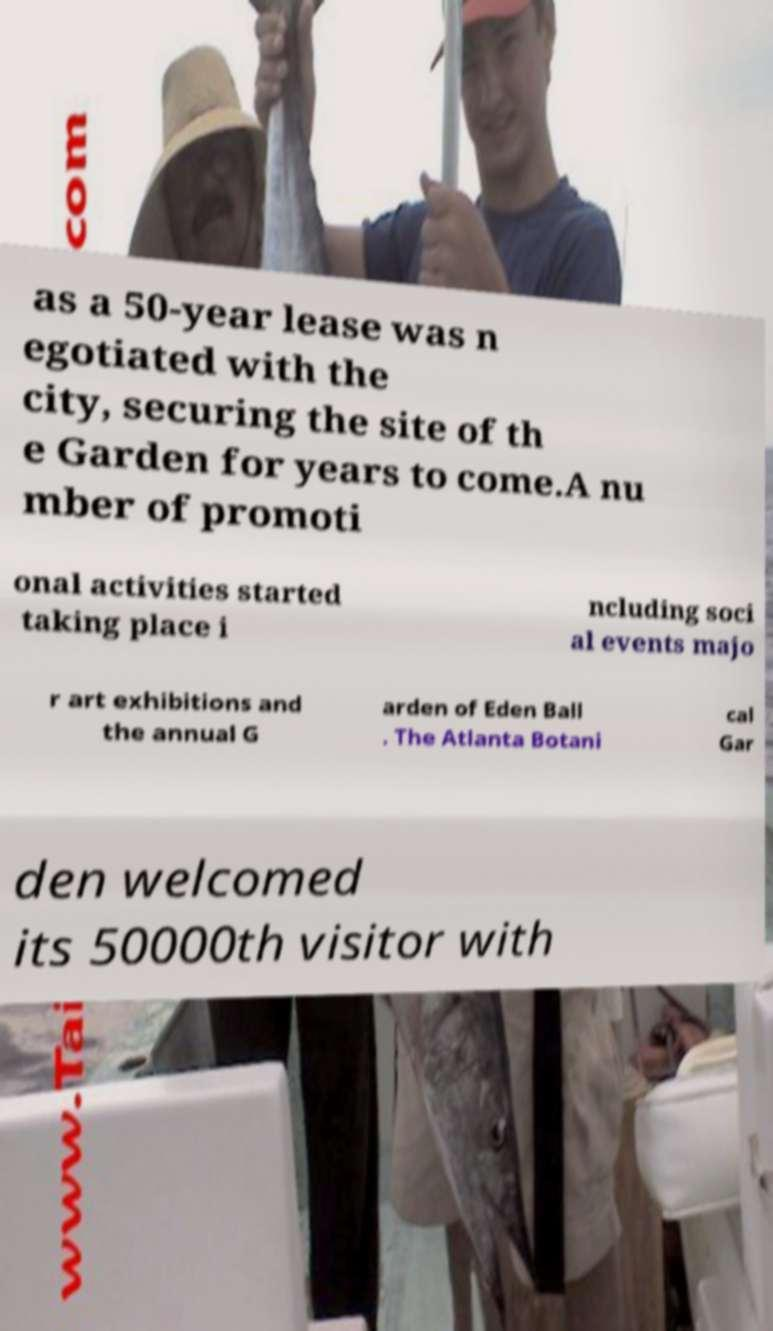What messages or text are displayed in this image? I need them in a readable, typed format. as a 50-year lease was n egotiated with the city, securing the site of th e Garden for years to come.A nu mber of promoti onal activities started taking place i ncluding soci al events majo r art exhibitions and the annual G arden of Eden Ball . The Atlanta Botani cal Gar den welcomed its 50000th visitor with 